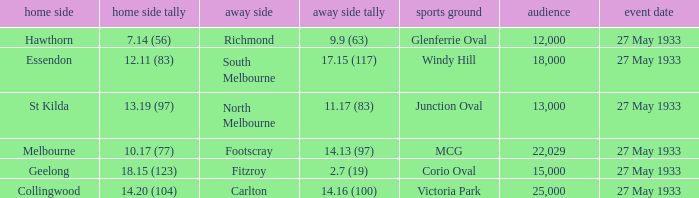In the match where the home team scored 14.20 (104), how many attendees were in the crowd? 25000.0. 